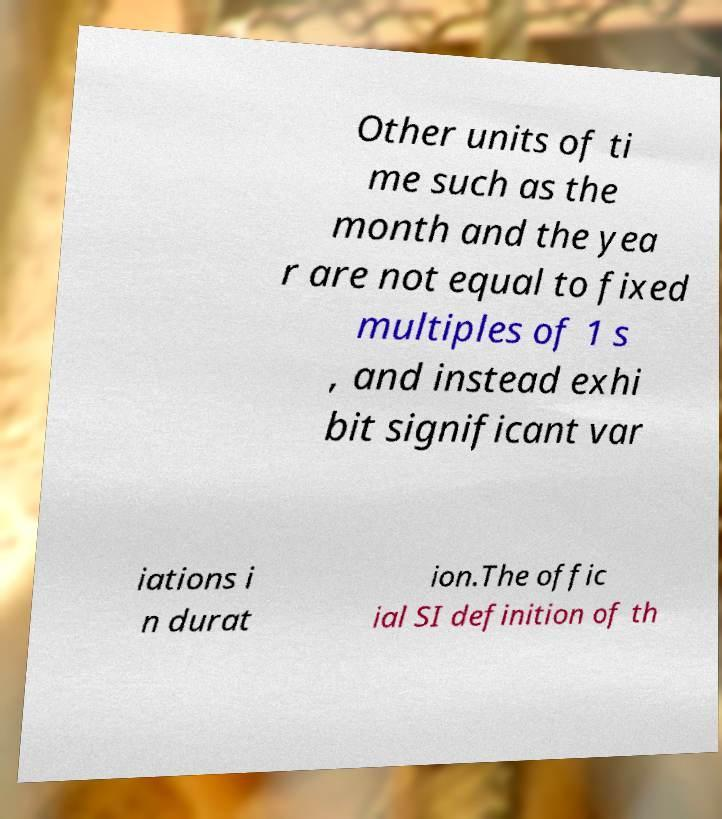For documentation purposes, I need the text within this image transcribed. Could you provide that? Other units of ti me such as the month and the yea r are not equal to fixed multiples of 1 s , and instead exhi bit significant var iations i n durat ion.The offic ial SI definition of th 